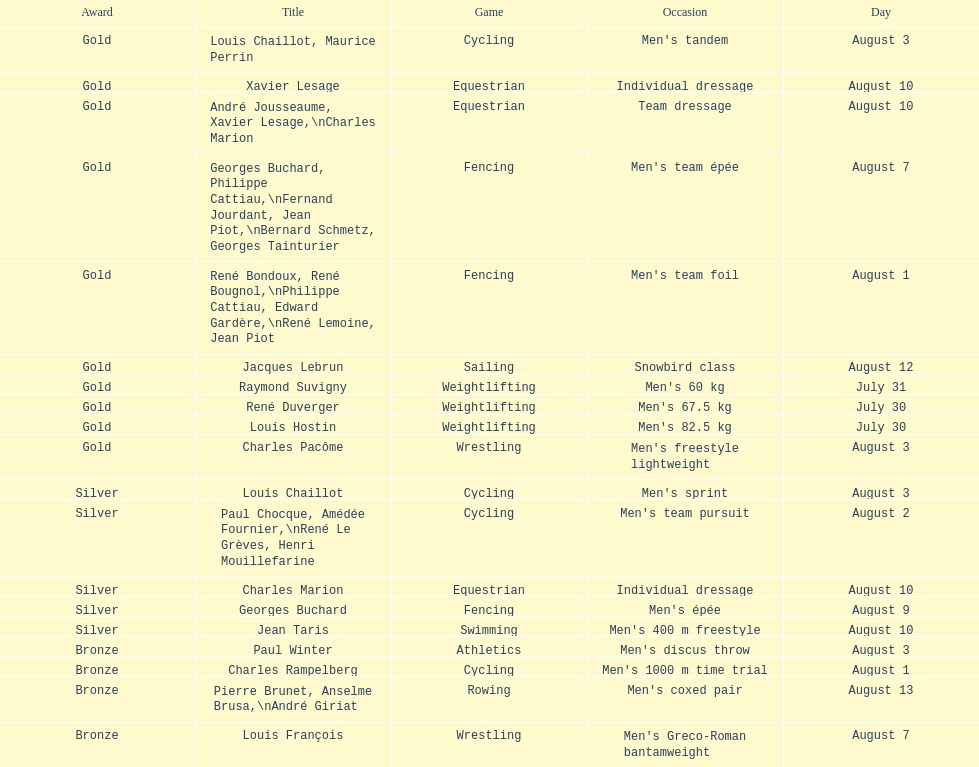In which sport did louis chaillot win a silver medal, in addition to his gold medal in cycling? Cycling. 